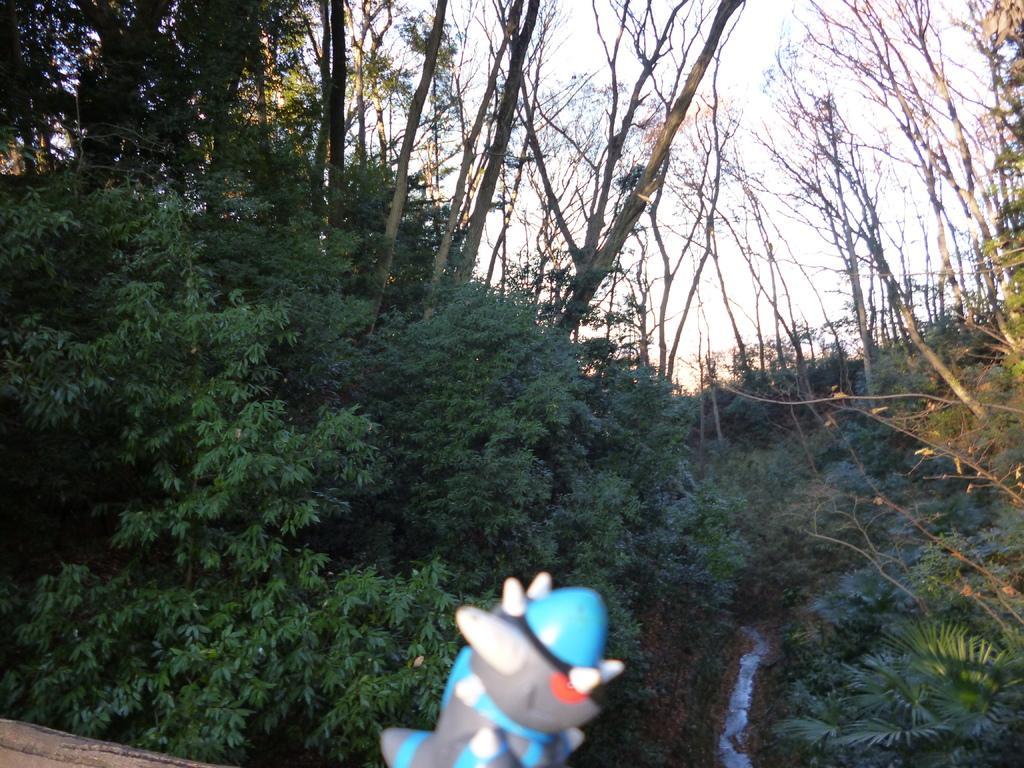How would you summarize this image in a sentence or two? This image is taken outdoors. In the background there are many trees and plants. At the top of the image there is a sky. At the bottom of the image there is a toy. 